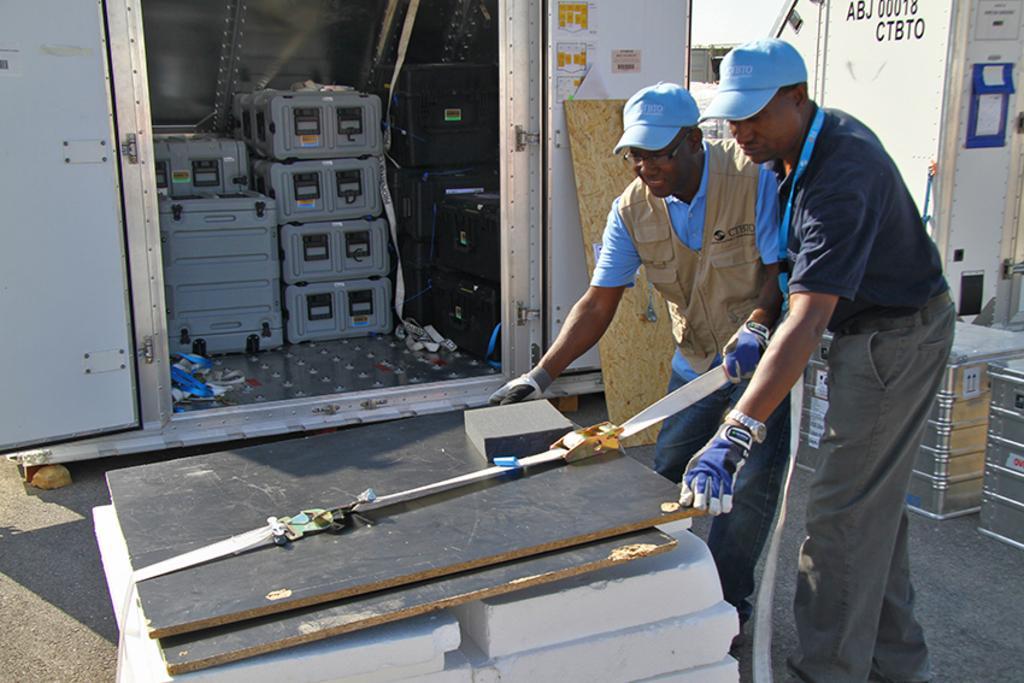Please provide a concise description of this image. In the picture we can see two men are standing and holding a wooden plank which is on the desk and the two men are in T-shirts, blue caps and gloves and beside the wooden plank we can see a store box with some boxes in it and door to it and behind men we can see a table and a wall beside it. 